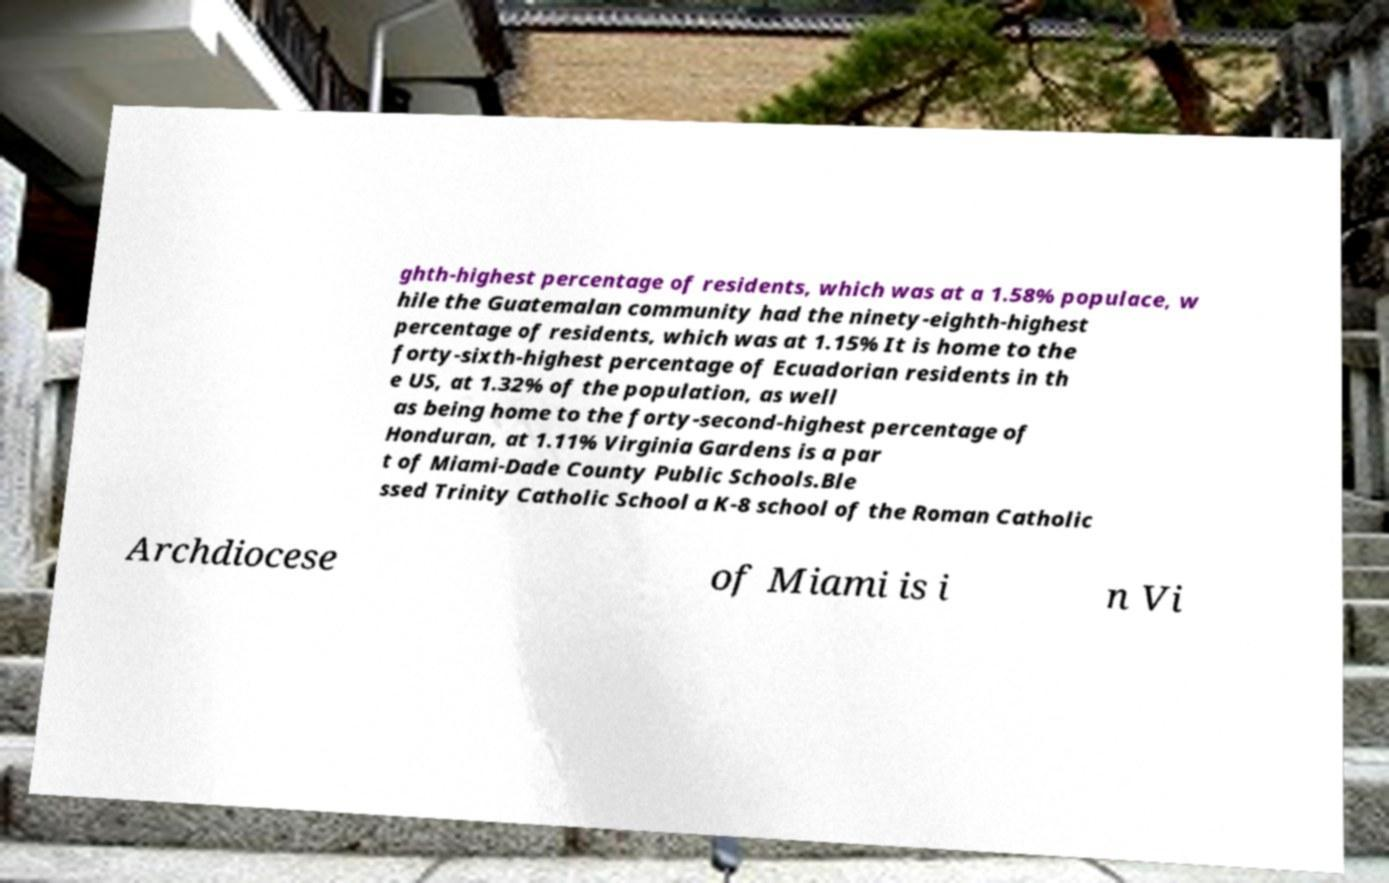Can you accurately transcribe the text from the provided image for me? ghth-highest percentage of residents, which was at a 1.58% populace, w hile the Guatemalan community had the ninety-eighth-highest percentage of residents, which was at 1.15% It is home to the forty-sixth-highest percentage of Ecuadorian residents in th e US, at 1.32% of the population, as well as being home to the forty-second-highest percentage of Honduran, at 1.11% Virginia Gardens is a par t of Miami-Dade County Public Schools.Ble ssed Trinity Catholic School a K-8 school of the Roman Catholic Archdiocese of Miami is i n Vi 